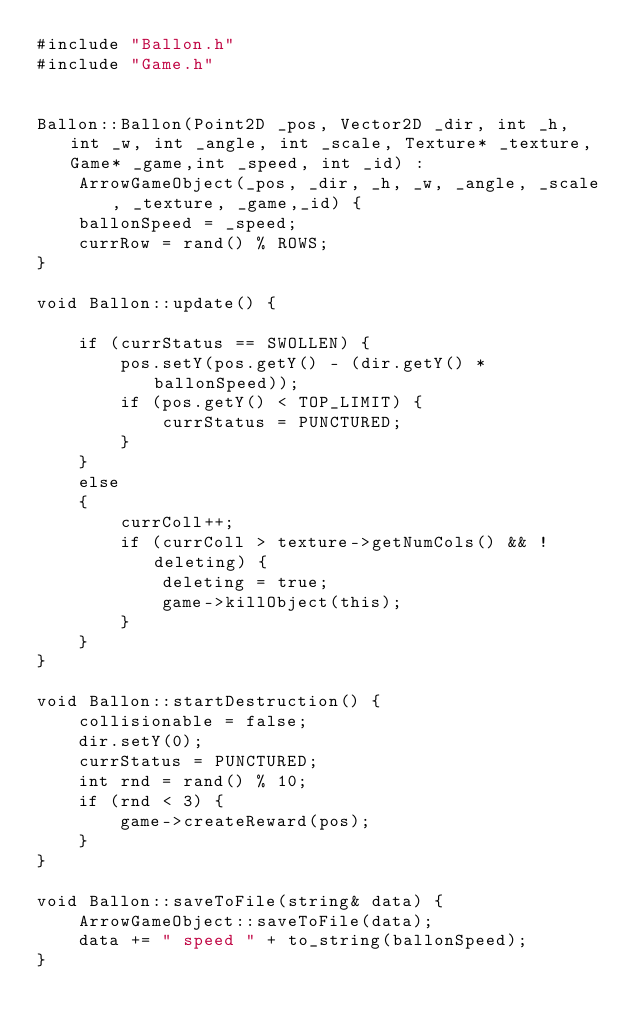Convert code to text. <code><loc_0><loc_0><loc_500><loc_500><_C++_>#include "Ballon.h"
#include "Game.h"


Ballon::Ballon(Point2D _pos, Vector2D _dir, int _h, int _w, int _angle, int _scale, Texture* _texture, Game* _game,int _speed, int _id) :
	ArrowGameObject(_pos, _dir, _h, _w, _angle, _scale, _texture, _game,_id) {
	ballonSpeed = _speed;
	currRow = rand() % ROWS;
}

void Ballon::update() {

	if (currStatus == SWOLLEN) {
		pos.setY(pos.getY() - (dir.getY() * ballonSpeed));
		if (pos.getY() < TOP_LIMIT) {
			currStatus = PUNCTURED;
		}
	}
	else
	{
		currColl++;
		if (currColl > texture->getNumCols() && !deleting) {
			deleting = true;
			game->killObject(this);
		}
	}
}

void Ballon::startDestruction() {
	collisionable = false;
	dir.setY(0);
	currStatus = PUNCTURED;
	int rnd = rand() % 10;
	if (rnd < 3) {
		game->createReward(pos);
	}
}

void Ballon::saveToFile(string& data) {
	ArrowGameObject::saveToFile(data);
	data += " speed " + to_string(ballonSpeed);
}

</code> 